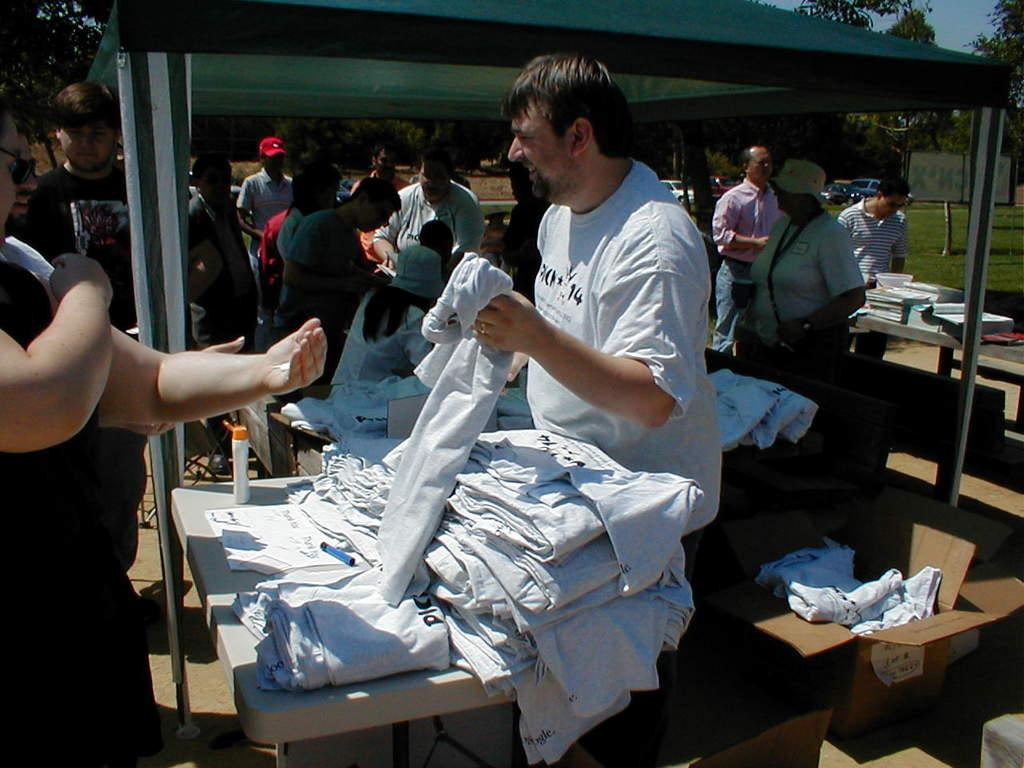What can be seen in the image involving multiple individuals? There is a group of people in the image. What is the man in the image holding? The man is holding a cloth in the image. What type of objects are present in the image that are typically used for storage or transportation? There are cardboard boxes in the image. What can be seen in the background of the image that indicates the presence of a larger object or structure? There is a vehicle in the background of the image. What type of natural scenery is visible in the background of the image? There are trees in the background of the image. What type of sweater is the man wearing in the image? The man is not wearing a sweater in the image; he is holding a cloth. What day of the week is depicted in the image? The day of the week is not mentioned or visible in the image. 